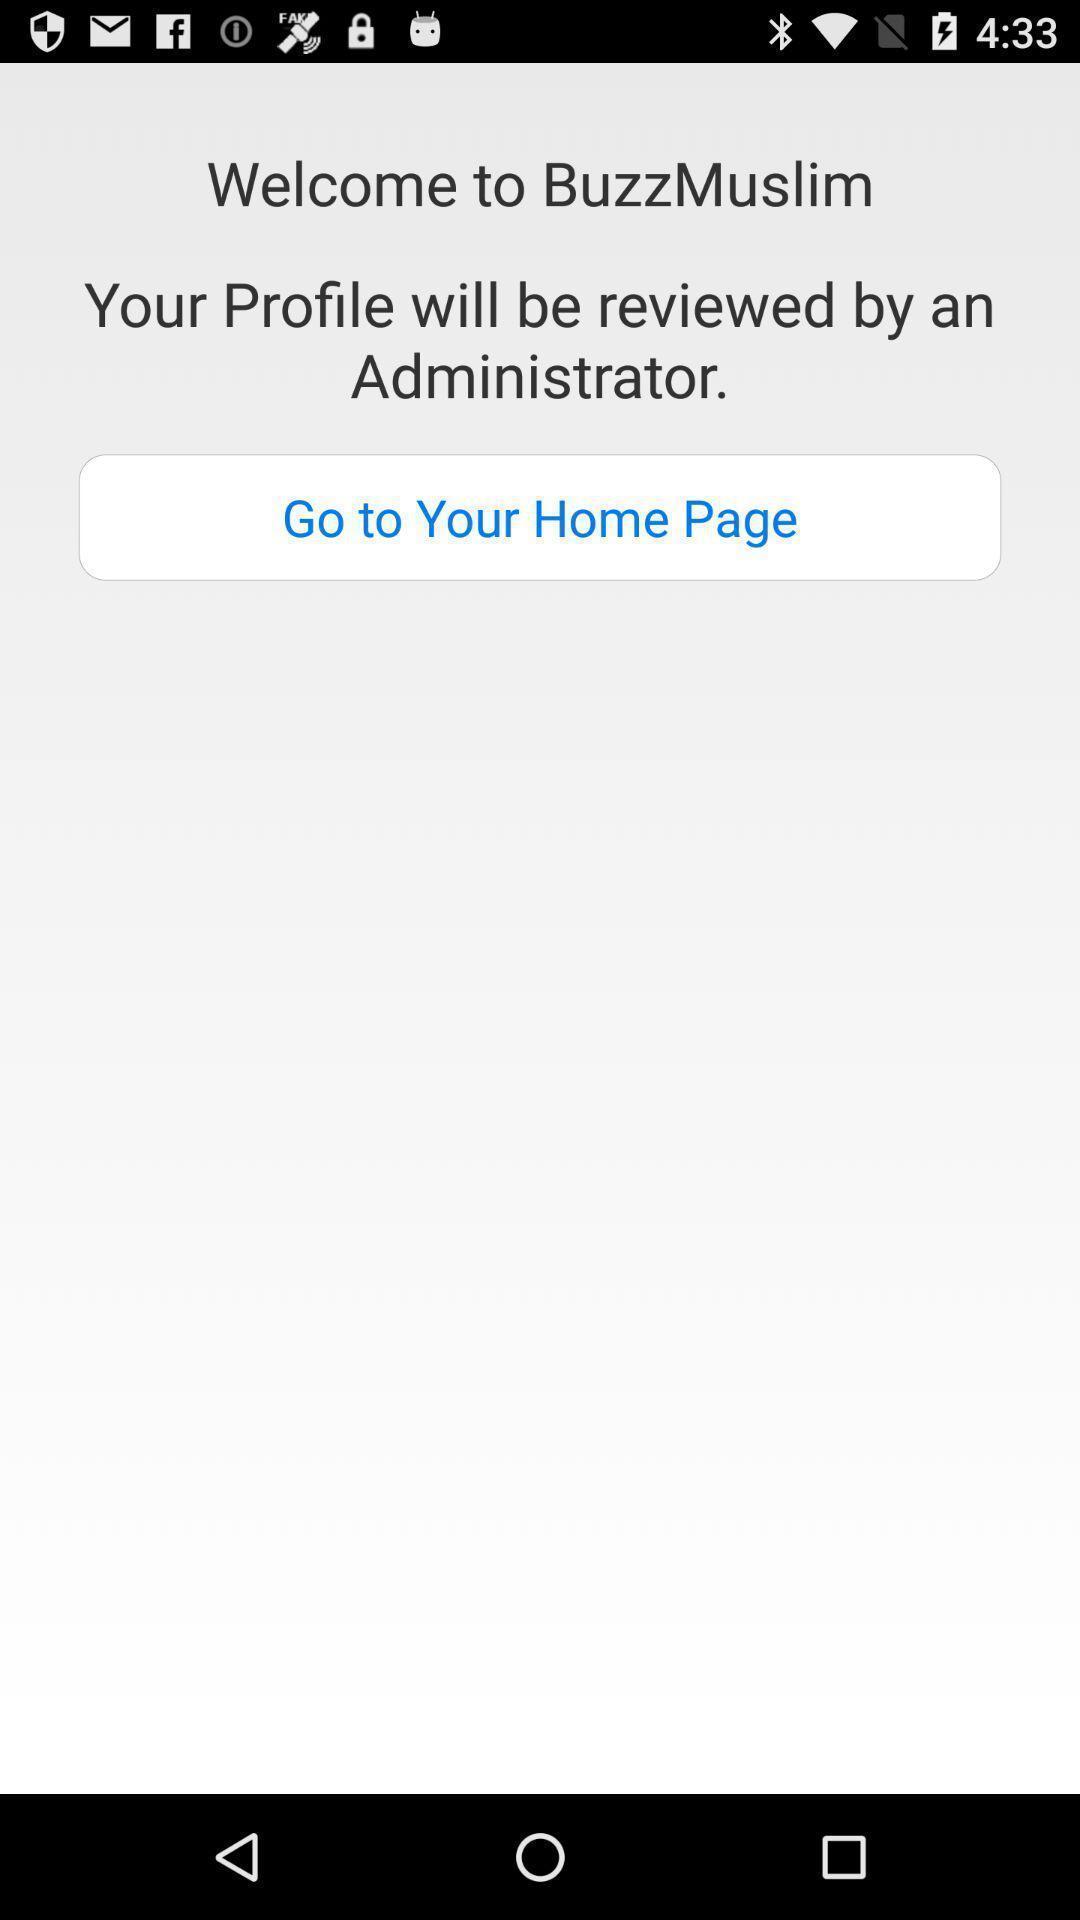Provide a textual representation of this image. Welcome page. 